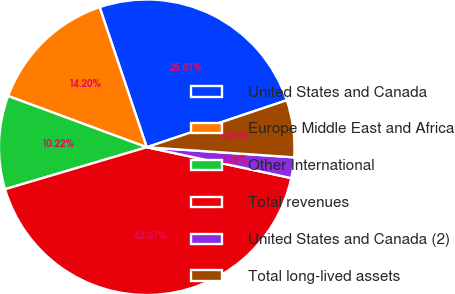<chart> <loc_0><loc_0><loc_500><loc_500><pie_chart><fcel>United States and Canada<fcel>Europe Middle East and Africa<fcel>Other International<fcel>Total revenues<fcel>United States and Canada (2)<fcel>Total long-lived assets<nl><fcel>25.01%<fcel>14.2%<fcel>10.22%<fcel>42.07%<fcel>2.26%<fcel>6.24%<nl></chart> 